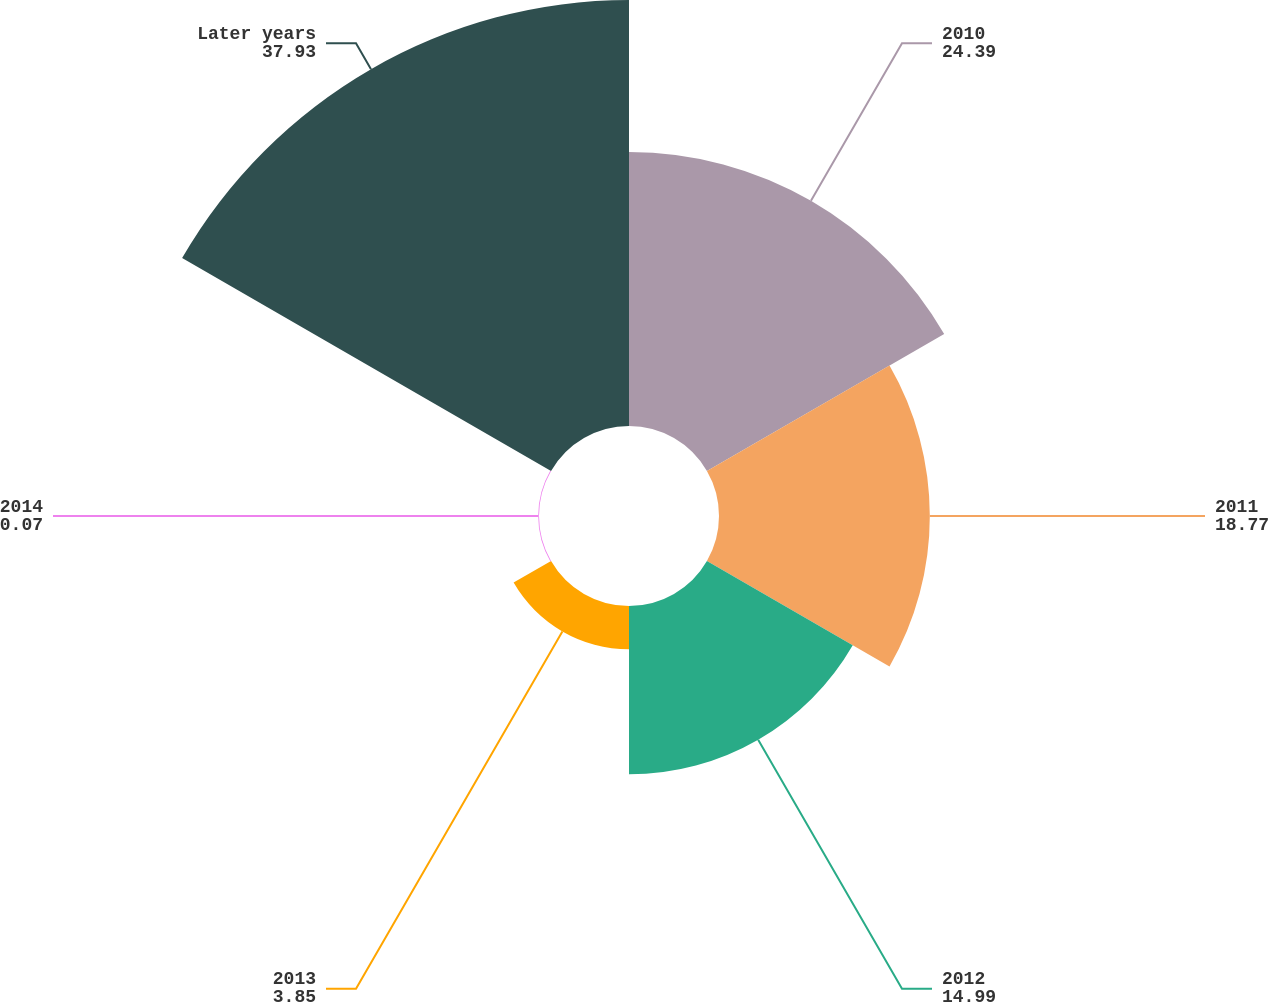Convert chart to OTSL. <chart><loc_0><loc_0><loc_500><loc_500><pie_chart><fcel>2010<fcel>2011<fcel>2012<fcel>2013<fcel>2014<fcel>Later years<nl><fcel>24.39%<fcel>18.77%<fcel>14.99%<fcel>3.85%<fcel>0.07%<fcel>37.93%<nl></chart> 